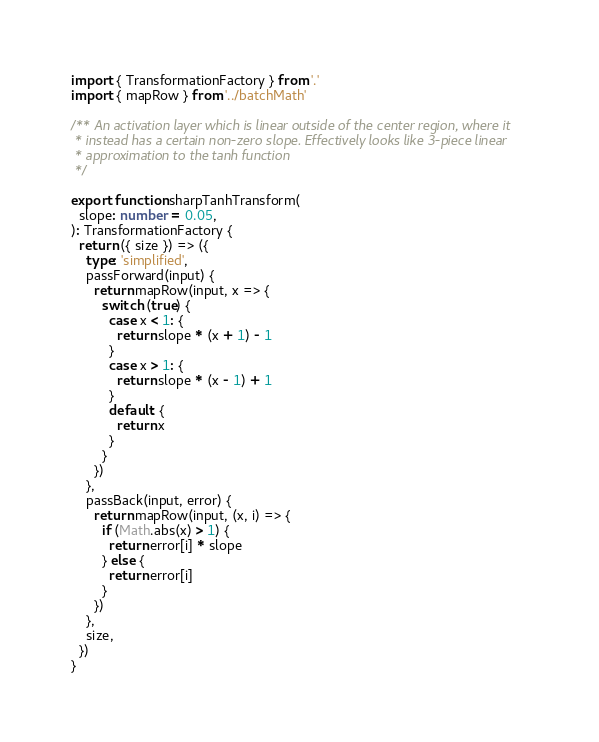Convert code to text. <code><loc_0><loc_0><loc_500><loc_500><_TypeScript_>import { TransformationFactory } from '.'
import { mapRow } from '../batchMath'

/** An activation layer which is linear outside of the center region, where it
 * instead has a certain non-zero slope. Effectively looks like 3-piece linear
 * approximation to the tanh function
 */

export function sharpTanhTransform(
  slope: number = 0.05,
): TransformationFactory {
  return ({ size }) => ({
    type: 'simplified',
    passForward(input) {
      return mapRow(input, x => {
        switch (true) {
          case x < 1: {
            return slope * (x + 1) - 1
          }
          case x > 1: {
            return slope * (x - 1) + 1
          }
          default: {
            return x
          }
        }
      })
    },
    passBack(input, error) {
      return mapRow(input, (x, i) => {
        if (Math.abs(x) > 1) {
          return error[i] * slope
        } else {
          return error[i]
        }
      })
    },
    size,
  })
}
</code> 